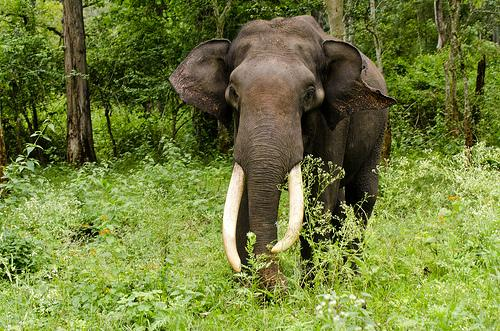What are some characteristics of the trees in the jungle? The trees have green leaves, tall brown wood trunks, thick jungle vines, and there is a bare tree trunk. How many orange flowers are there, and where are they located? There are two sets of small orange flowers on plants, one to the left and one to the right of the elephant. Discuss the details of the elephant's tusks in the image. The elephant has two long white tusks, one left ivory tusk, and one right ivory tusk. Estimate the number of identifiable objects in the image. There are at least 30 identifiable objects in the image. Describe the elephant's ears in the image. The elephant has a large floppy gray left ear and a large floppy right ear. Mention some of the objects in the scene besides the elephant. A tree trunk, small orange flowers, a wooded area, and a brush filled area. What are some of the features that can be observed on the elephant's trunk? The elephant's trunk is strong and efficient, with wrinkles on top and touching the ground. Briefly describe what the left eye of the elephant looks like. The left eye of the elephant is sunken temple with wrinkles on top of trunk. What is the primary animal depicted in the image? A large gray elephant in a grassy field with tusks. What type of location is the elephant situated in? The elephant is walking out of trees into a grassy field. Identify and describe the segmented areas in the image. large elephant, tusks, wooded area, grassy field, tree trunks, small orange flowers, elephant ear, and tree leaves How would you describe the emotion or mood of the image? calm Find the object in the image that corresponds to "left eye of elephant." X:301 Y:79 Width:18 Height:18 Rate the image quality on a scale from 1 (poor) to 10 (excellent). 8 What is the relationship between the elephant and the tree trunk? The tree trunk is part of the wooded area which the elephant is walking out of. Does the image appear well-lit and have clear detail? Yes What type of environment is the elephant in? wooded and grassy field Are there any visible injuries or deformities on the elephant? No visible injuries or deformities are present. Find the object in the image that corresponds to "two white elephant tusks." X:219 Y:154 Width:91 Height:91 Which plant is taller: the one with green leaves at the top or the one with small orange flowers? the plant with small orange flowers Identify any anomalies or unusual elements in the image. There are no anomalies or unusual elements. What are some visible attributes of the elephant's trunk? long, gray, and wrinkled What is the interaction between the elephant and its surroundings in the image? The elephant is walking out of the wooded area into a grassy field. Are there any identifiable patterns on the elephant? no identifiable patterns are visible Is there any text visible in the image? If so, what does it say?  No text is visible in the image. What kind of animal is in the image? elephant In the image, what is the sentiment portrayed: positive, negative or neutral? neutral Describe the scene in the image. An image of a large gray elephant with tusks walking out of a wooded area into a grassy field surrounded by trees, small orange flowers, and tree trunks. 